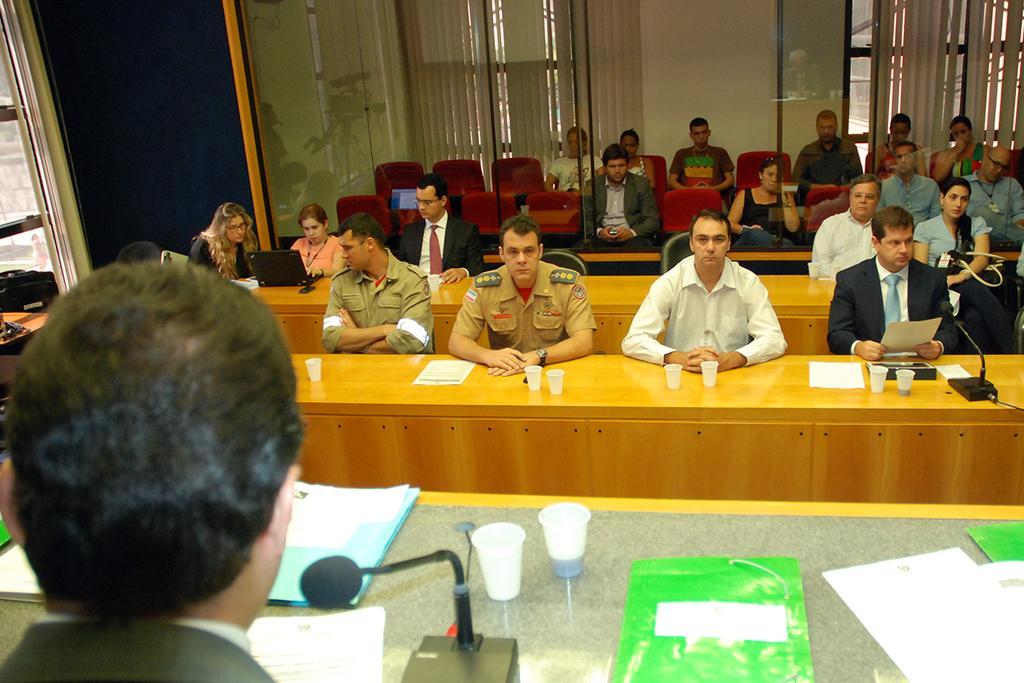Please provide a concise description of this image. In this image I can see there are group of people who are sitting on a chair in front of the table. On the table we have a few cups, a microphone and other objects on it. 